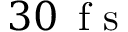Convert formula to latex. <formula><loc_0><loc_0><loc_500><loc_500>3 0 \, f s</formula> 